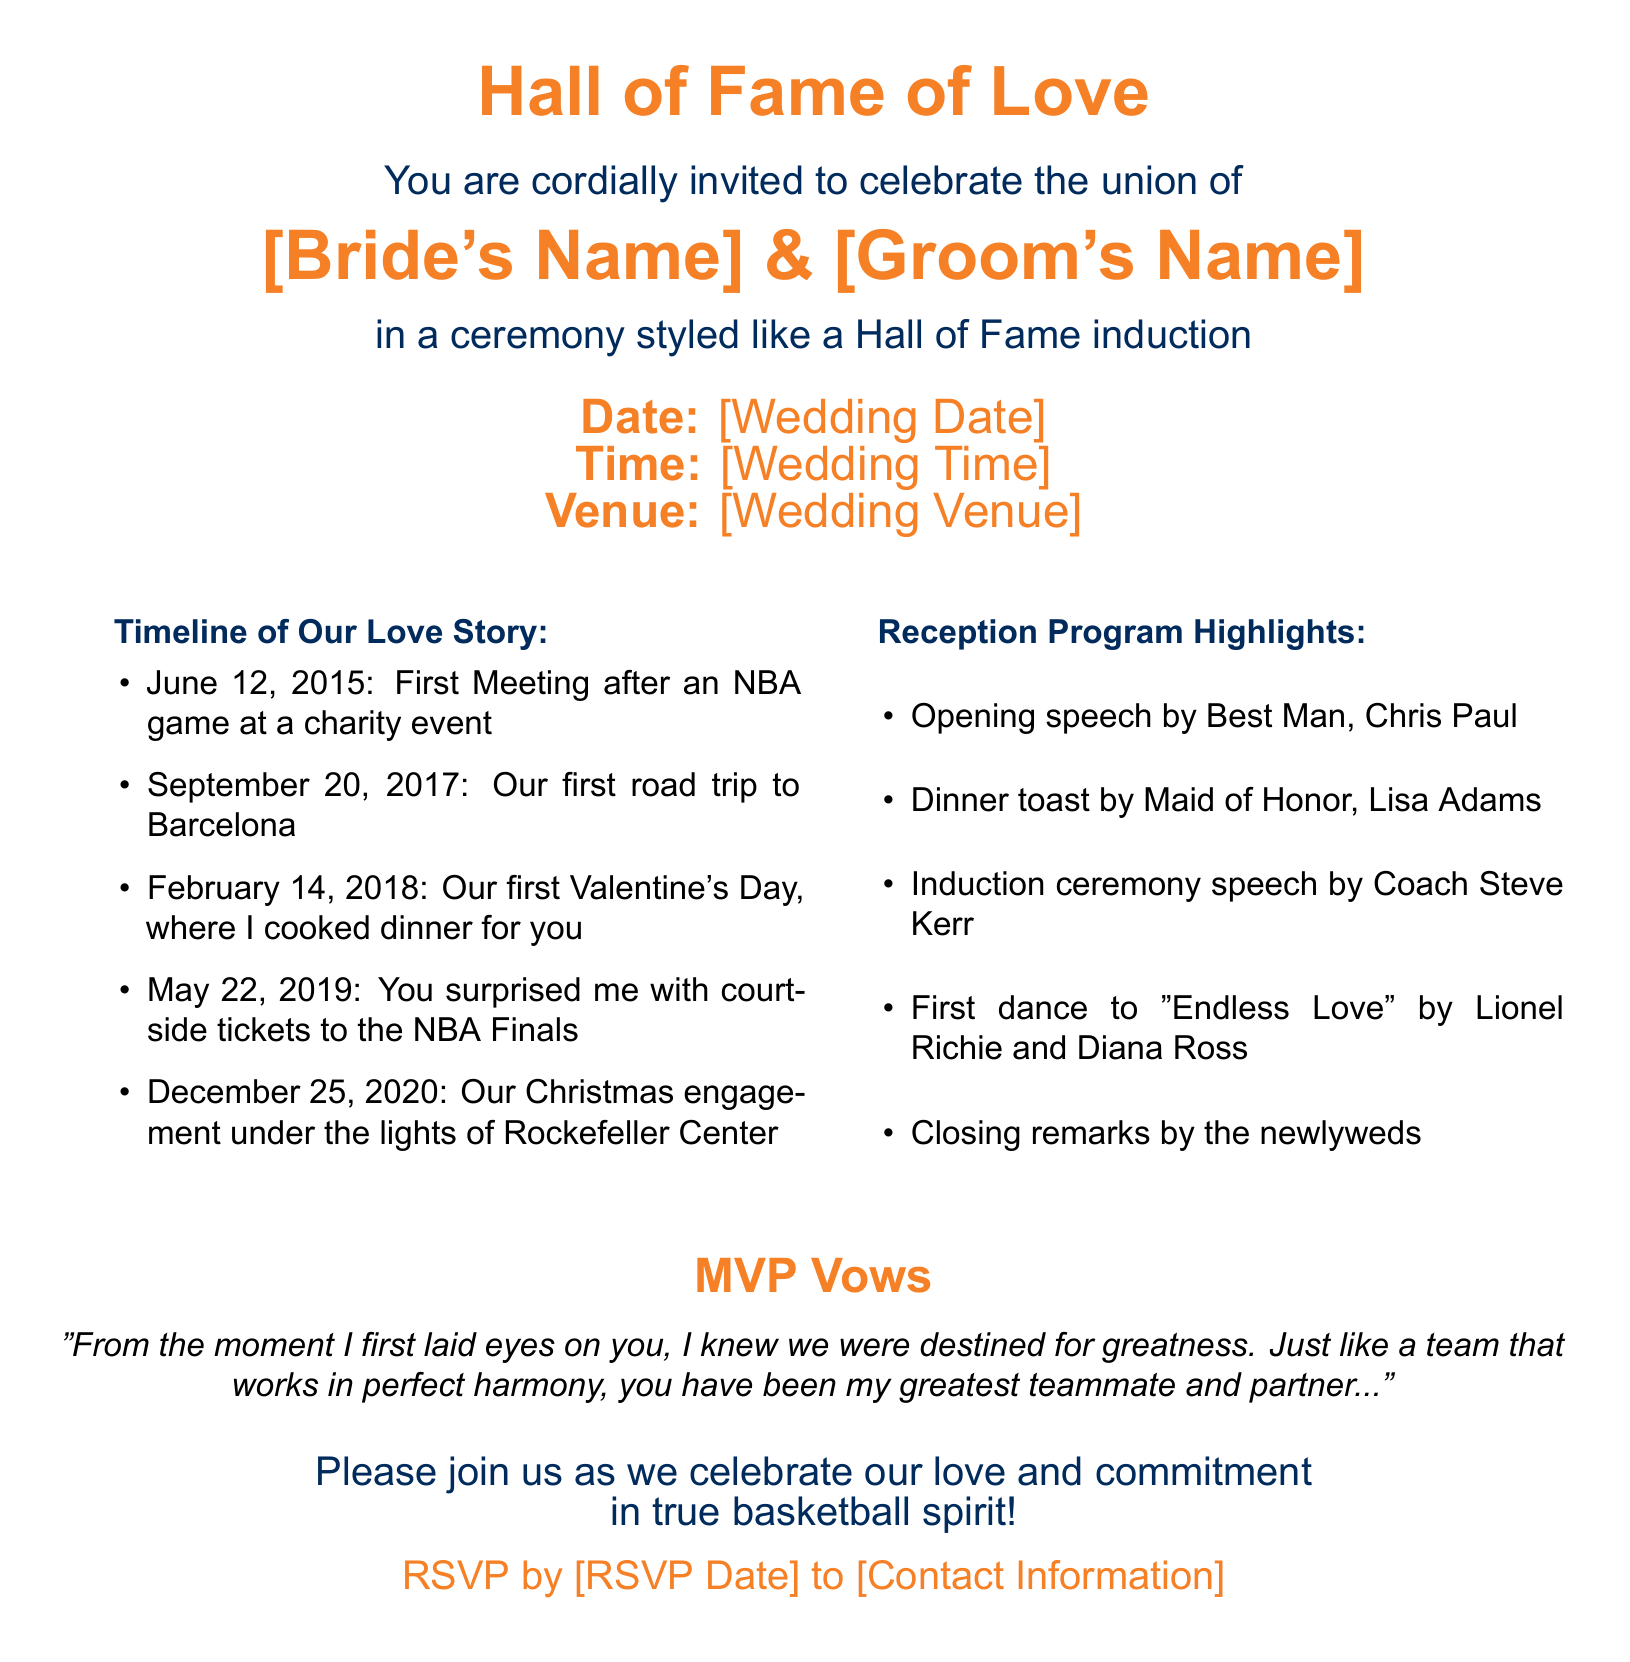What is the title of the event? The title of the event is prominently displayed at the top of the document as "Hall of Fame of Love."
Answer: Hall of Fame of Love Who will be the Best Man? The document specifies that Chris Paul will deliver the opening speech as the Best Man.
Answer: Chris Paul When did the couple first meet? The timeline of their love story lists their first meeting date as June 12, 2015.
Answer: June 12, 2015 What is the first dance song? The document states the first dance will be to "Endless Love" by Lionel Richie and Diana Ross.
Answer: Endless Love What color is associated with the wedding invitation? The document features a basketball orange color, which is used throughout the invitation.
Answer: basketball orange Who is giving the induction ceremony speech? The invitation states that Coach Steve Kerr will be giving the induction ceremony speech.
Answer: Coach Steve Kerr When is the RSVP deadline? The RSVP deadline is provided in the invitation but is represented as "[RSVP Date]."
Answer: [RSVP Date] What is the location of the ceremony? The wedding venue is indicated in the document as "[Wedding Venue]."
Answer: [Wedding Venue] What type of event is this invitation for? The invitation is clearly for a wedding celebration styled like a Hall of Fame induction ceremony.
Answer: wedding celebration 